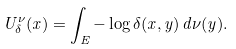<formula> <loc_0><loc_0><loc_500><loc_500>U ^ { \nu } _ { \delta } ( x ) = \int _ { E } - \log \delta ( x , y ) \, d \nu ( y ) .</formula> 